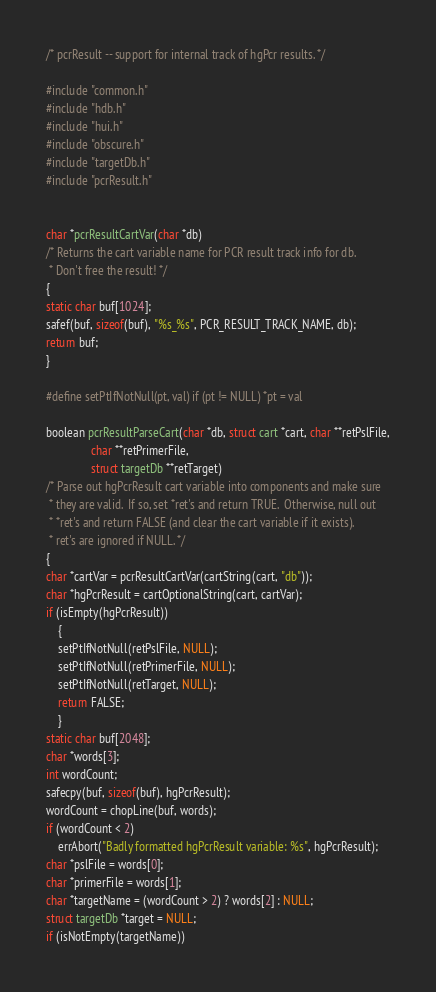Convert code to text. <code><loc_0><loc_0><loc_500><loc_500><_C_>/* pcrResult -- support for internal track of hgPcr results. */

#include "common.h"
#include "hdb.h"
#include "hui.h"
#include "obscure.h"
#include "targetDb.h"
#include "pcrResult.h"


char *pcrResultCartVar(char *db)
/* Returns the cart variable name for PCR result track info for db. 
 * Don't free the result! */
{
static char buf[1024];
safef(buf, sizeof(buf), "%s_%s", PCR_RESULT_TRACK_NAME, db);
return buf;
}

#define setPtIfNotNull(pt, val) if (pt != NULL) *pt = val

boolean pcrResultParseCart(char *db, struct cart *cart, char **retPslFile,
			   char **retPrimerFile,
			   struct targetDb **retTarget)
/* Parse out hgPcrResult cart variable into components and make sure
 * they are valid.  If so, set *ret's and return TRUE.  Otherwise, null out 
 * *ret's and return FALSE (and clear the cart variable if it exists).  
 * ret's are ignored if NULL. */
{
char *cartVar = pcrResultCartVar(cartString(cart, "db"));
char *hgPcrResult = cartOptionalString(cart, cartVar);
if (isEmpty(hgPcrResult))
    {
    setPtIfNotNull(retPslFile, NULL);
    setPtIfNotNull(retPrimerFile, NULL);
    setPtIfNotNull(retTarget, NULL);
    return FALSE;
    }
static char buf[2048];
char *words[3];
int wordCount;
safecpy(buf, sizeof(buf), hgPcrResult);
wordCount = chopLine(buf, words);
if (wordCount < 2)
    errAbort("Badly formatted hgPcrResult variable: %s", hgPcrResult);
char *pslFile = words[0];
char *primerFile = words[1];
char *targetName = (wordCount > 2) ? words[2] : NULL;
struct targetDb *target = NULL;
if (isNotEmpty(targetName))</code> 